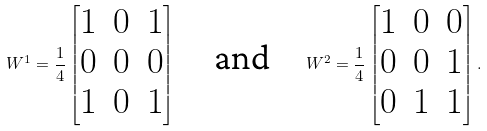<formula> <loc_0><loc_0><loc_500><loc_500>W ^ { 1 } = \frac { 1 } { 4 } \begin{bmatrix} 1 & 0 & 1 \\ 0 & 0 & 0 \\ 1 & 0 & 1 \end{bmatrix} \quad \text {and} \quad W ^ { 2 } = \frac { 1 } { 4 } \begin{bmatrix} 1 & 0 & 0 \\ 0 & 0 & 1 \\ 0 & 1 & 1 \end{bmatrix} .</formula> 